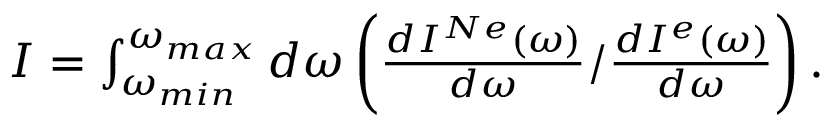Convert formula to latex. <formula><loc_0><loc_0><loc_500><loc_500>\begin{array} { r } { I = \int _ { \omega _ { \min } } ^ { \omega _ { \max } } d \omega \left ( \frac { d I ^ { N e } ( \omega ) } { d \omega } / \frac { d I ^ { e } ( \omega ) } { d \omega } \right ) . } \end{array}</formula> 